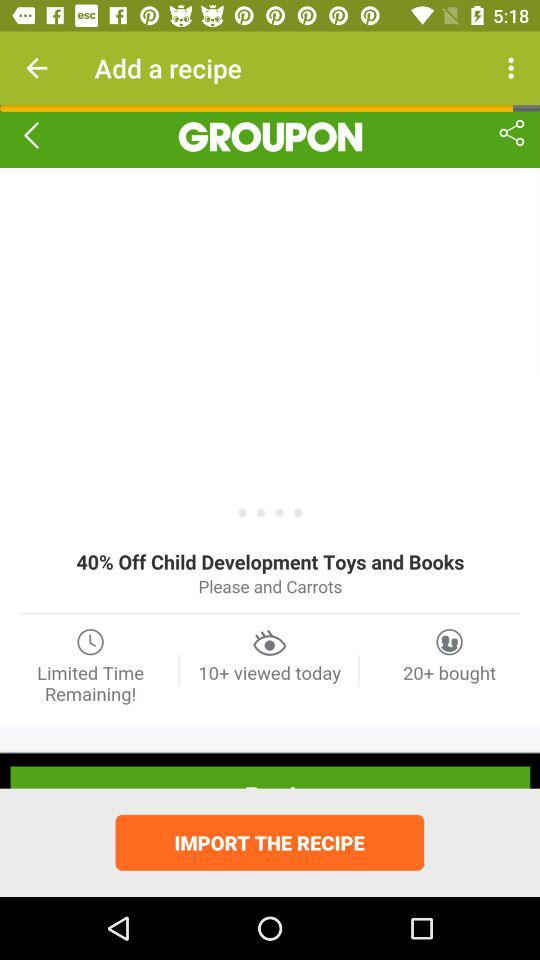How much of a percentage is off for books and toys in child development? The percentage off is 40. 